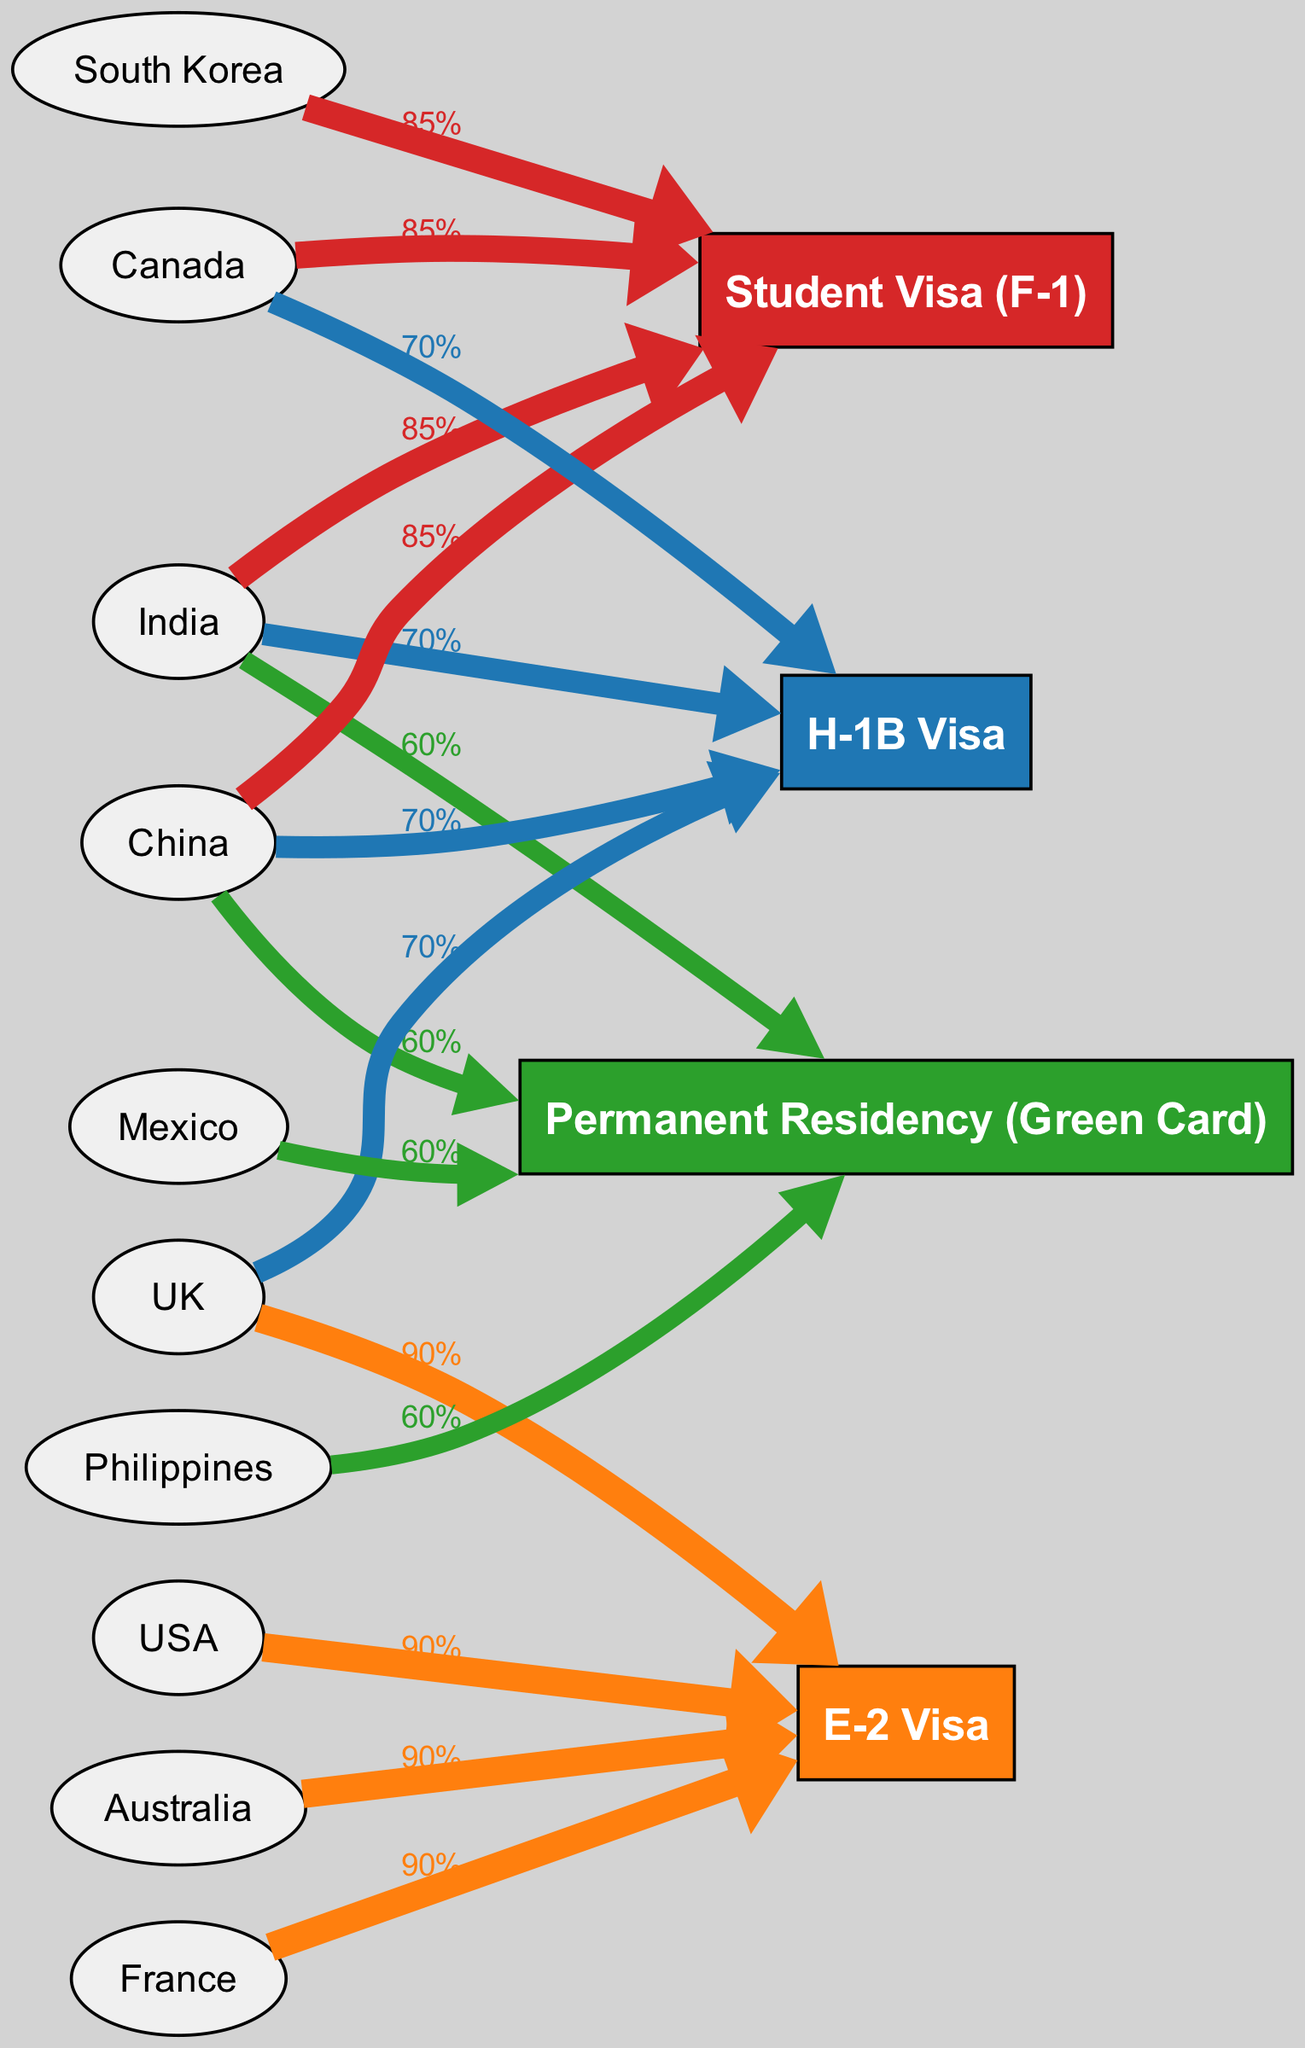What is the success rate of the H-1B Visa? The diagram indicates that the H-1B Visa has a success rate labeled as "70%." This information is directly available on the node representing the H-1B Visa in the diagram.
Answer: 70% Which nationality has the highest visa success rate? The E-2 Visa shows a success rate of "90%," which is the highest compared to the other visa types displayed. This information can be read directly from the E-2 Visa node.
Answer: 90% How many nationalities are connected to the Student Visa? The diagram illustrates that the Student Visa (F-1) is connected to four nationalities: China, India, South Korea, and Canada. By counting the distinct connections, we find there are four.
Answer: 4 Which visa type has connections from India? The diagram displays connections from India to the H-1B Visa and the Permanent Residency (Green Card). By examining the edges from the India node, both visa types show direct connections.
Answer: H-1B Visa, Permanent Residency (Green Card) If Kenya were added, which visa type might they apply for? Given the nationalities for each visa type, Kenya is not represented in any current visa connections. However, since it is not linked to any shown visa types, we cannot directly determine a likely visa to apply for without more information about Kenya's eligibility. Therefore, a potential choice could be E-2 Visa since it is generally for nationals of countries with investment treaties, assuming further data supports this.
Answer: Unknown, but potentially E-2 Visa What is the total number of edges coming from the UK? From the diagram, the UK is connected to two visa types: H-1B Visa and E-2 Visa. Counting the edges shows that the UK has two outgoing connections.
Answer: 2 Which nationality has the lowest success rate displayed? The Permanent Residency (Green Card) shows a success rate of "60%," which is the lowest among the provided visa options in the diagram. This rate is evident in the node associated with the Green Card visa type.
Answer: 60% Which visa type connects to the highest number of nationalities? The H-1B Visa connects to four nationalities: India, China, Canada, and UK. This is the maximum connection displayed for any visa type based on the diagram's information.
Answer: H-1B Visa How does the success rate for the E-2 Visa compare to the Student Visa? The E-2 Visa has a success rate of "90%," while the Student Visa (F-1) has a success rate of "85%." Therefore, the E-2 Visa has a higher success rate compared to the Student Visa.
Answer: Higher than Student Visa 